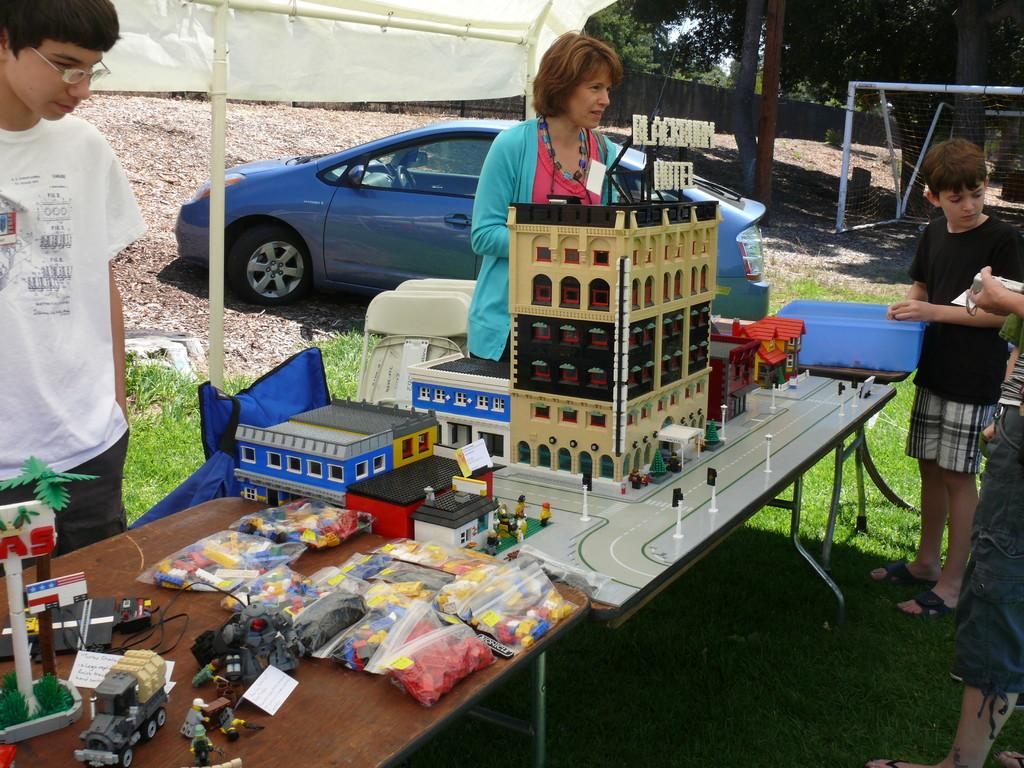How many people are in the image? There are three people in the image: a woman and two boys. What are the boys doing in the image? One of the boys is looking at toys, while the other boy's activity is not specified. What type of toys can be seen in the image? The toys include building blocks and wires. What other objects can be seen in the image? There is a car, a basket, and rods in the image. What can be seen in the background of the image? There are trees and a wall in the image. What type of business is being conducted in the image? There is no indication of any business being conducted in the image. What things are being used to create humor in the image? There is no humor or comedic elements present in the image. 